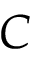<formula> <loc_0><loc_0><loc_500><loc_500>C</formula> 